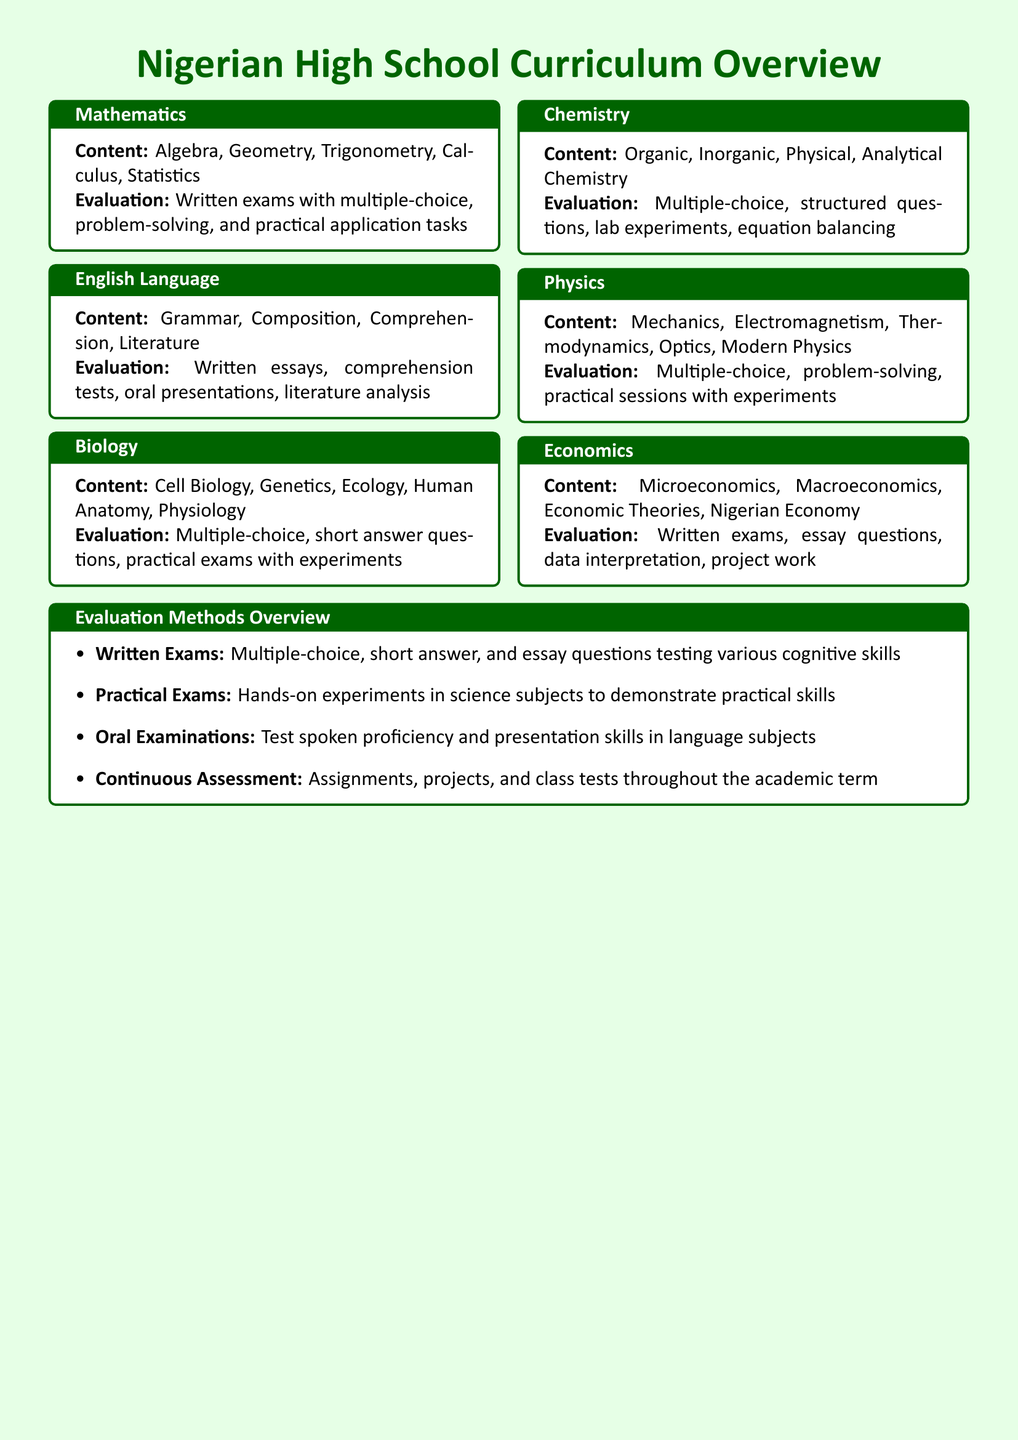What are the key areas of study in Mathematics? The Mathematics subject includes topics such as Algebra, Geometry, Trigonometry, Calculus, and Statistics, as listed in the document.
Answer: Algebra, Geometry, Trigonometry, Calculus, Statistics How is the English Language evaluated? The evaluation methods for English Language include written essays, comprehension tests, oral presentations, and literature analysis, as specified in the document.
Answer: Written essays, comprehension tests, oral presentations, literature analysis What type of questions are used in Chemistry evaluations? The Chemistry evaluations comprise multiple-choice, structured questions, lab experiments, and equation balancing, as mentioned in the document.
Answer: Multiple-choice, structured questions, lab experiments, equation balancing What practical skills are assessed in Biology? The practical skills in Biology are assessed through practical exams with experiments, as indicated in the document.
Answer: Practical exams with experiments What does the term "Continuous Assessment" refer to? Continuous Assessment refers to assignments, projects, and class tests throughout the academic term, as explained in the evaluation methods section of the document.
Answer: Assignments, projects, and class tests Which subject includes topics on the Nigerian Economy? Economics is the subject that includes Microeconomics, Macroeconomics, Economic Theories, and Nigerian Economy according to the document.
Answer: Economics What methods are included for assessing language proficiency? Oral examinations are the methods used for assessing spoken proficiency and presentation skills in language subjects, as stated in the document.
Answer: Oral examinations What kind of exams test hands-on skills in science subjects? Practical exams test hands-on skills in science subjects, as outlined in the evaluation methods section of the document.
Answer: Practical exams 